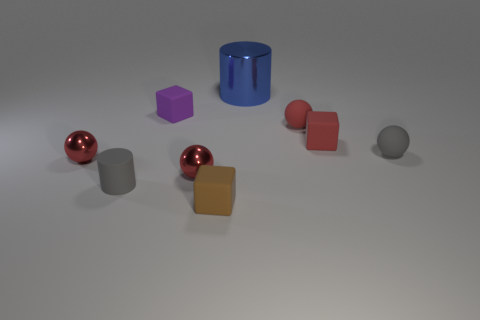Subtract all red balls. How many were subtracted if there are1red balls left? 2 Subtract all blue cylinders. How many red spheres are left? 3 Subtract all spheres. How many objects are left? 5 Subtract 0 cyan cylinders. How many objects are left? 9 Subtract all tiny metallic cylinders. Subtract all red rubber objects. How many objects are left? 7 Add 7 big blue things. How many big blue things are left? 8 Add 2 tiny purple rubber cubes. How many tiny purple rubber cubes exist? 3 